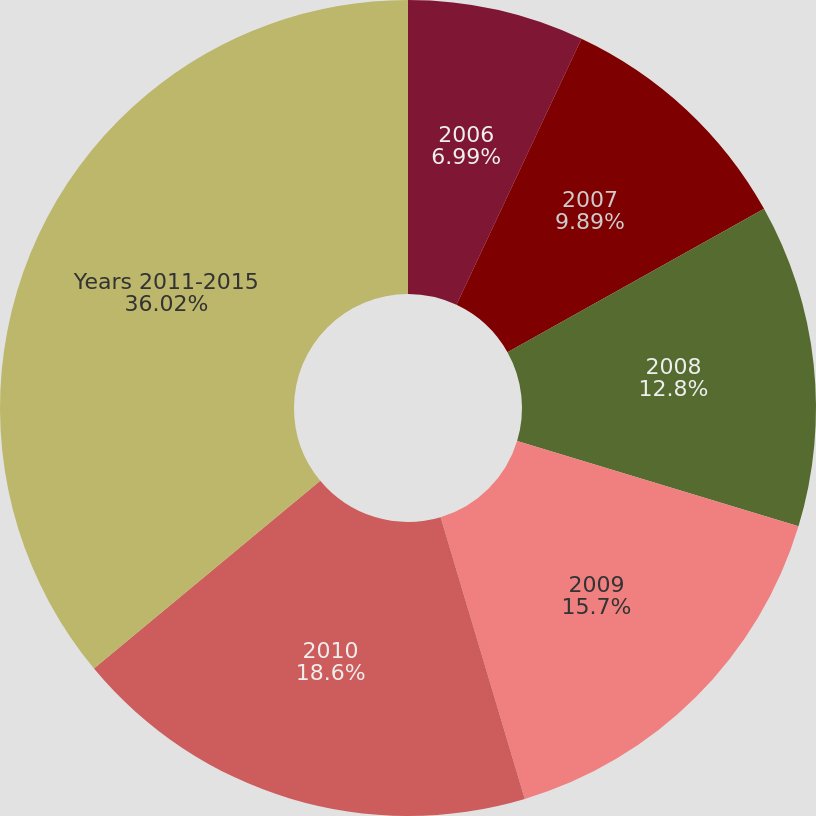Convert chart. <chart><loc_0><loc_0><loc_500><loc_500><pie_chart><fcel>2006<fcel>2007<fcel>2008<fcel>2009<fcel>2010<fcel>Years 2011-2015<nl><fcel>6.99%<fcel>9.89%<fcel>12.8%<fcel>15.7%<fcel>18.6%<fcel>36.02%<nl></chart> 